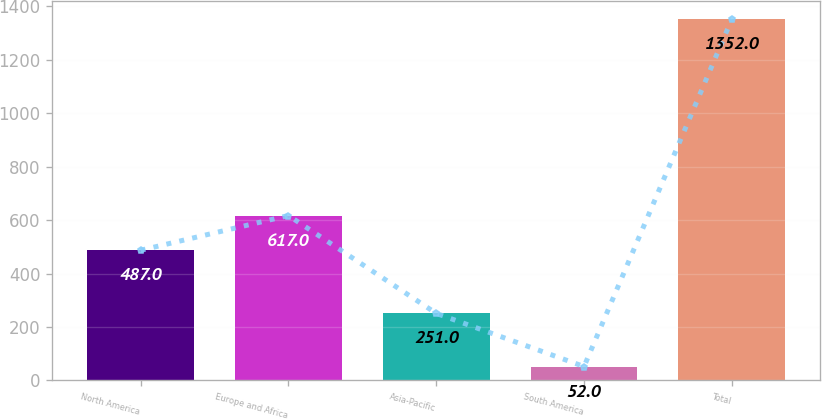Convert chart to OTSL. <chart><loc_0><loc_0><loc_500><loc_500><bar_chart><fcel>North America<fcel>Europe and Africa<fcel>Asia-Pacific<fcel>South America<fcel>Total<nl><fcel>487<fcel>617<fcel>251<fcel>52<fcel>1352<nl></chart> 